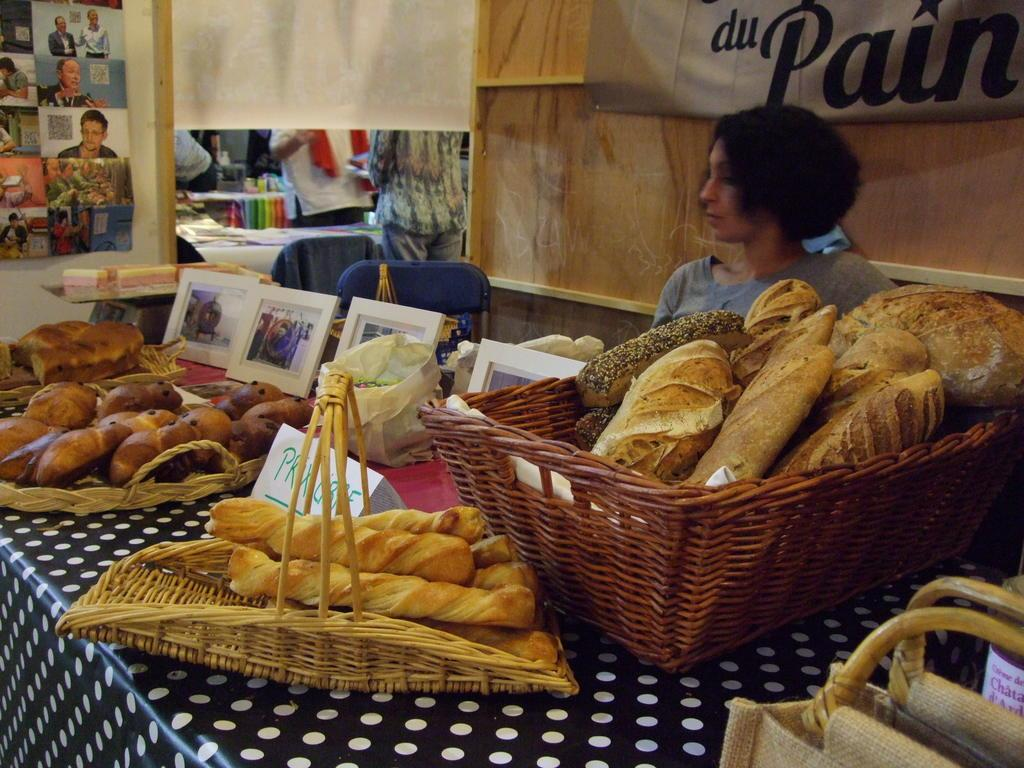What objects are on the table in the image? There are baskets, pictures, bags, and food on the table in the image. What else can be seen in the image besides the table? There are banners, chairs, and people in the image. What is the person beside the table doing? The person beside the table is not specified in the facts, so we cannot determine their actions. What is on the wall in the image? There is a poster on the wall in the image. What type of pets are visible in the image? There are no pets visible in the image. What color is the person's shirt in the image? The facts do not mention the color of the person's shirt, so we cannot determine the color. What type of quartz can be seen in the image? There is no quartz present in the image. 